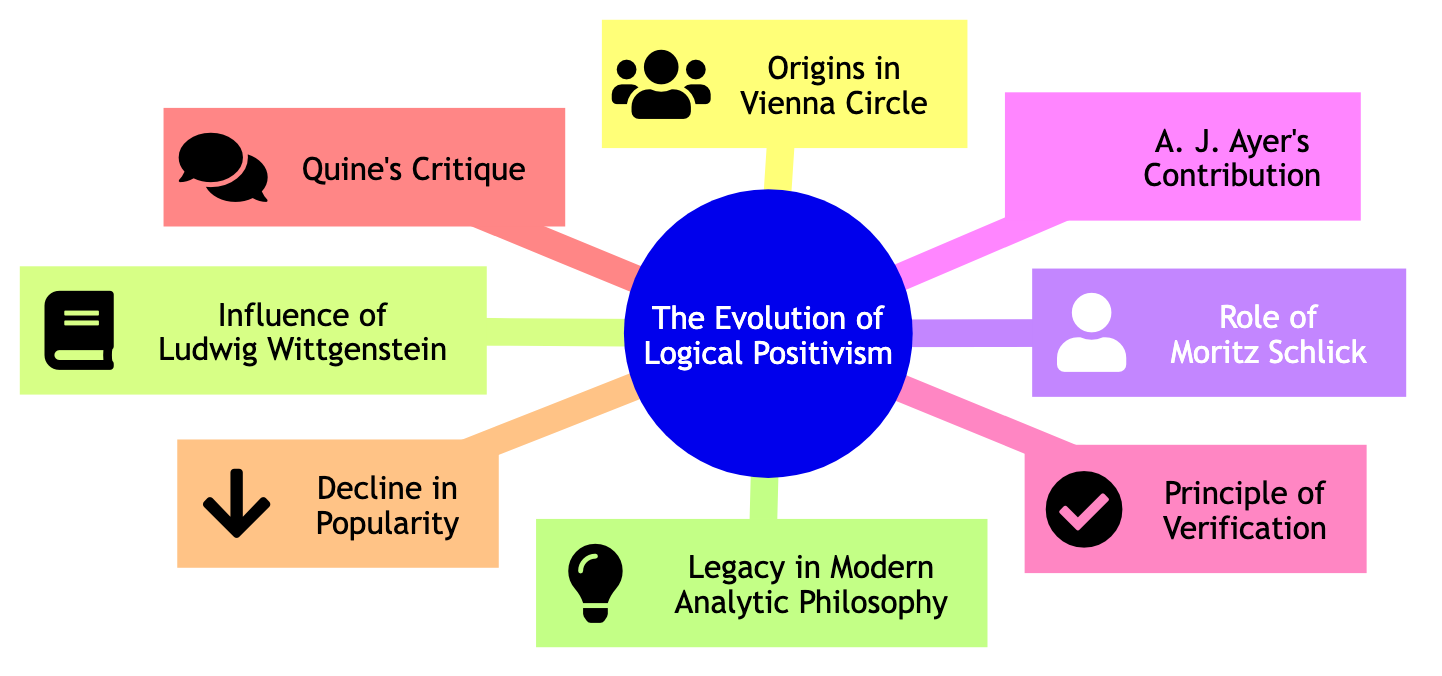What is the first node in the diagram? The first node in the diagram is "Origins in Vienna Circle," which is listed at the top as the main starting point for the concept map.
Answer: Origins in Vienna Circle How many main elements are there in the concept map? There are eight main elements in the concept map, each representing a key aspect of the evolution of Logical Positivism.
Answer: 8 What principle is central to Logical Positivism? The principle that is central to Logical Positivism is the "Principle of Verification," which articulates the criteria for the meaningfulness of propositions.
Answer: Principle of Verification Which figure contributed a popular book in the English-speaking world? A. J. Ayer contributed a significant book titled "Language, Truth and Logic," which played a crucial role in popularizing Logical Positivism in the English-speaking context.
Answer: A. J. Ayer What critique did W.V.O. Quine present about Logical Positivism? W.V.O. Quine's critique focused on the "analytic-synthetic distinction," challenging one of the foundational concepts of Logical Positivism.
Answer: Analytic-synthetic distinction What is noted as a significant legacy of Logical Positivism? Despite its decline, Logical Positivism's legacy is evident in "Modern Analytic Philosophy," especially influencing discussions in the philosophy of language and science.
Answer: Modern Analytic Philosophy Which element shows a decline in influence from the late 1950s onward? The element illustrating this trend is "Decline in Popularity," indicating that Logical Positivism began to lose its prominence during that period.
Answer: Decline in Popularity Who was a leading figure of the Vienna Circle? Moritz Schlick is recognized as a leading figure of the Vienna Circle, contributing significantly to the movement and the promotion of its principles.
Answer: Moritz Schlick 